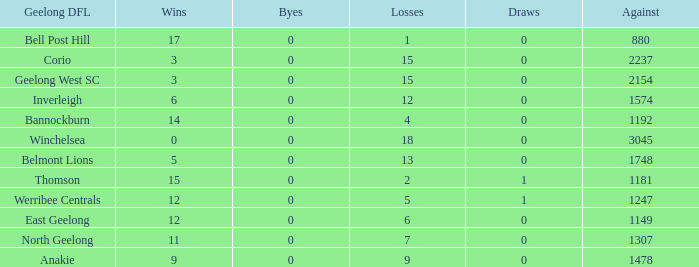What are the average losses for Geelong DFL of Bell Post Hill where the draws are less than 0? None. 